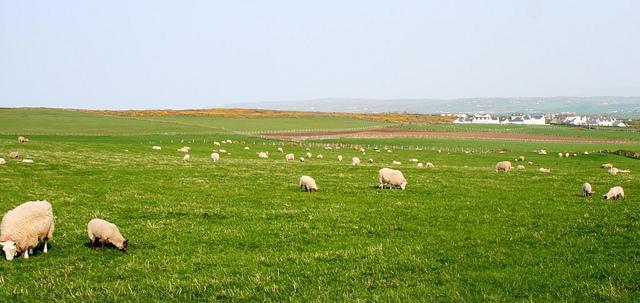What do these animals have?
Pick the correct solution from the four options below to address the question.
Options: Wings, long necks, wool, quills. Wool. 